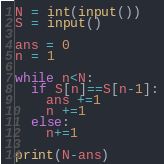Convert code to text. <code><loc_0><loc_0><loc_500><loc_500><_Python_>N = int(input())
S = input()

ans = 0
n = 1

while n<N:
  if S[n]==S[n-1]:
    ans +=1
    n +=1
  else:
    n+=1

print(N-ans)</code> 